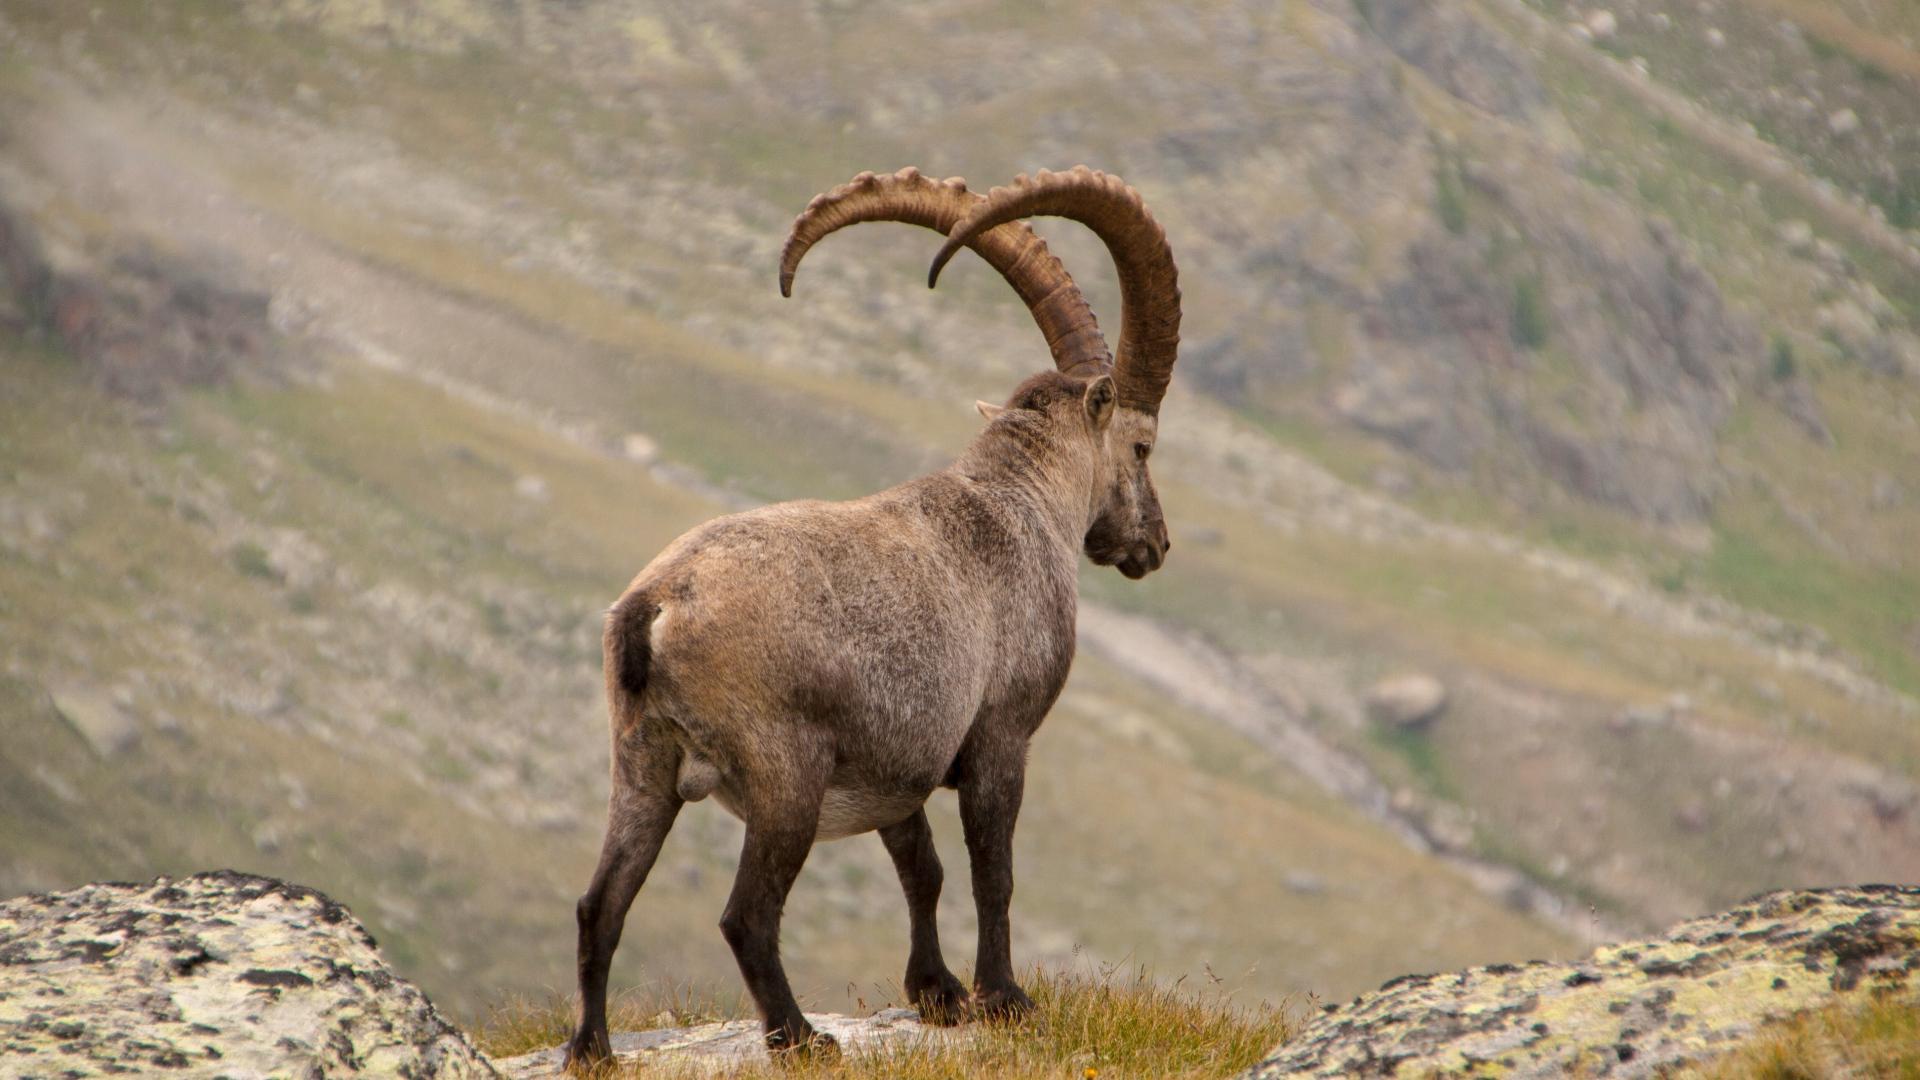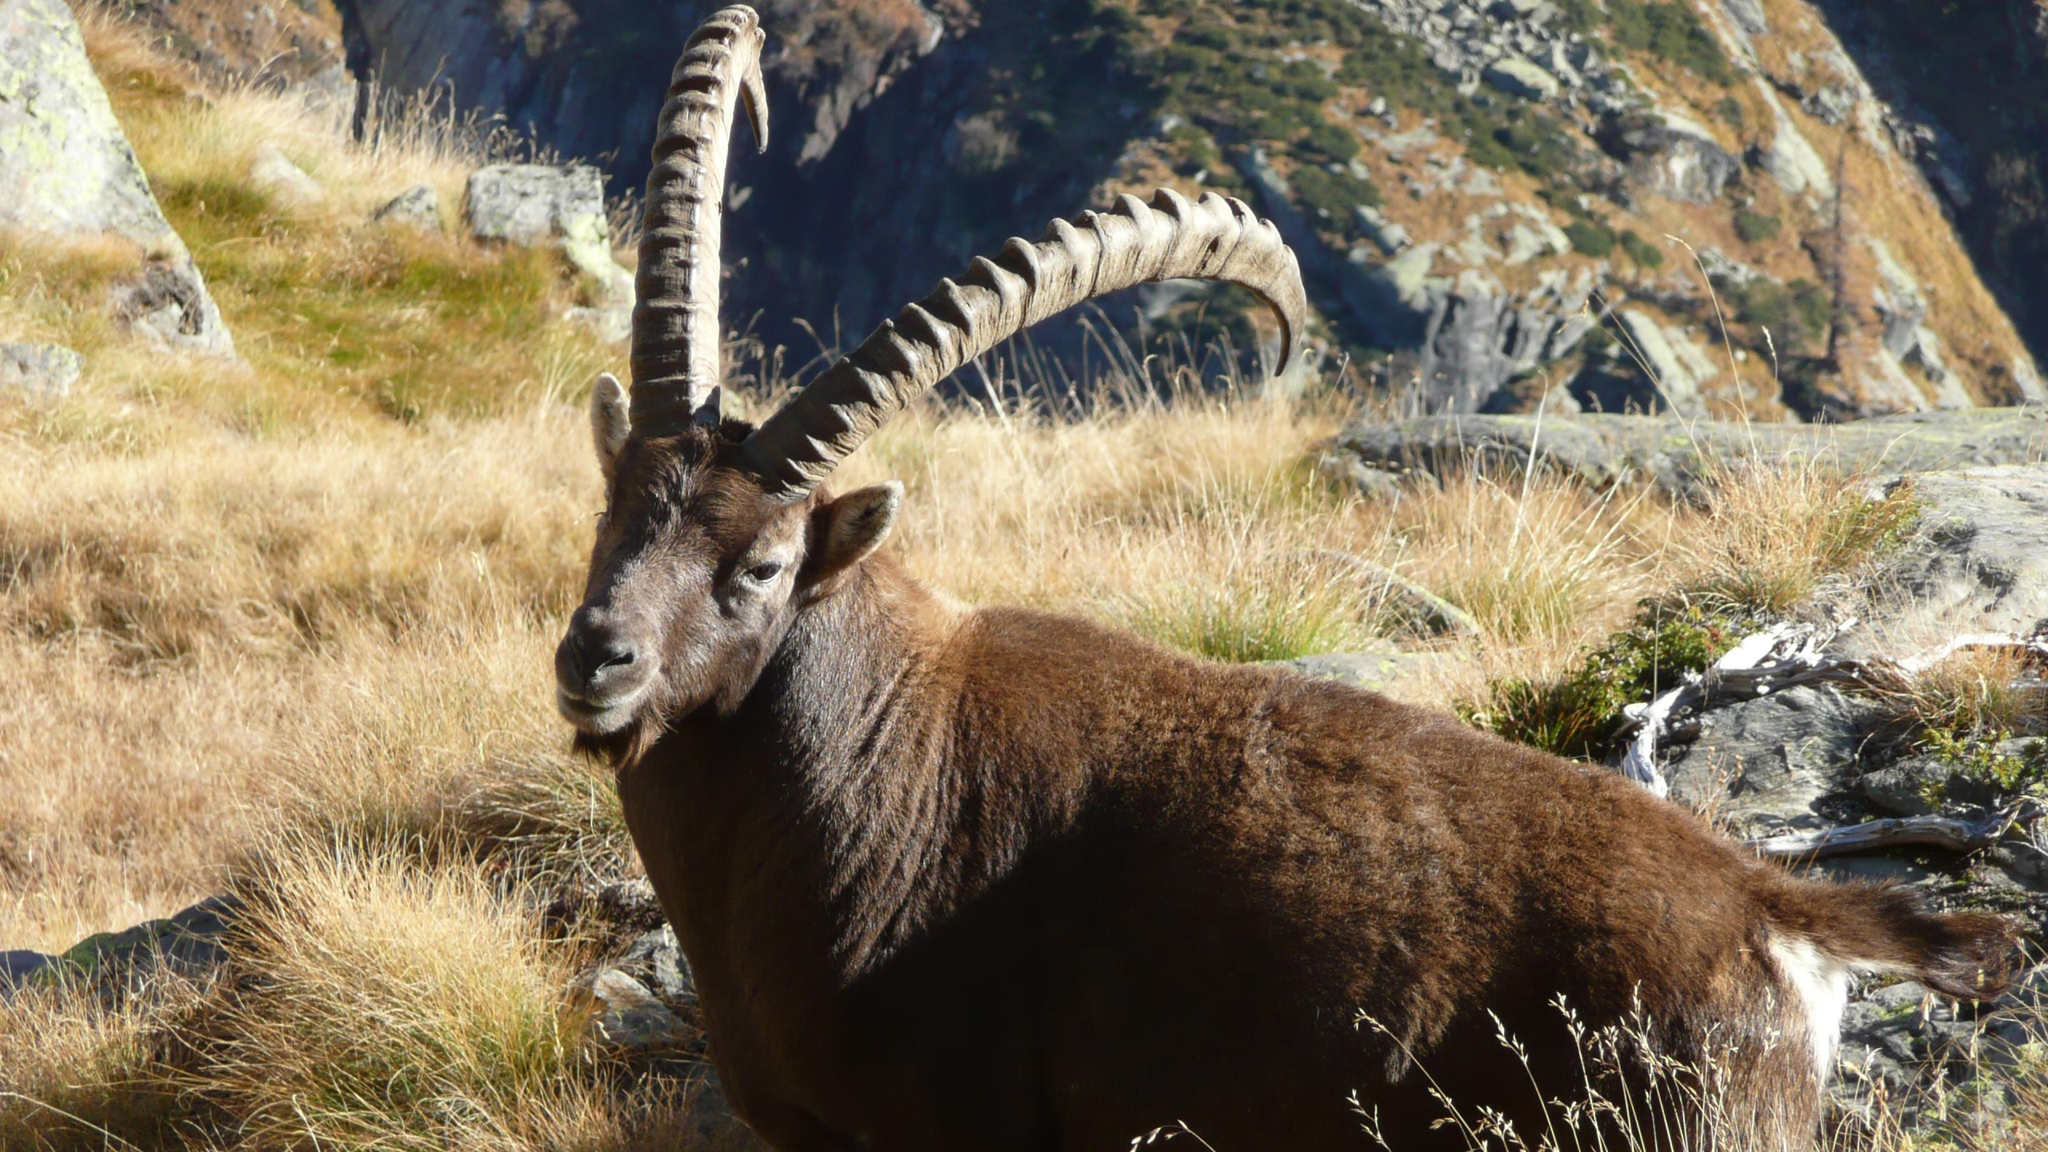The first image is the image on the left, the second image is the image on the right. Examine the images to the left and right. Is the description "In one image an animal with long, curved horns is standing in a rocky area, while a similar animal in the other image is lying down with its head erect." accurate? Answer yes or no. Yes. The first image is the image on the left, the second image is the image on the right. Examine the images to the left and right. Is the description "Each image depicts exactly one long-horned hooved animal." accurate? Answer yes or no. Yes. 